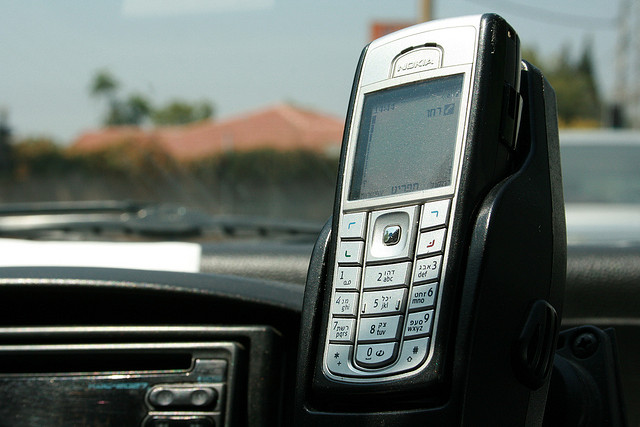Identify the text contained in this image. 2 1 NOKIA 3 6 4 5 7 9 8 0 